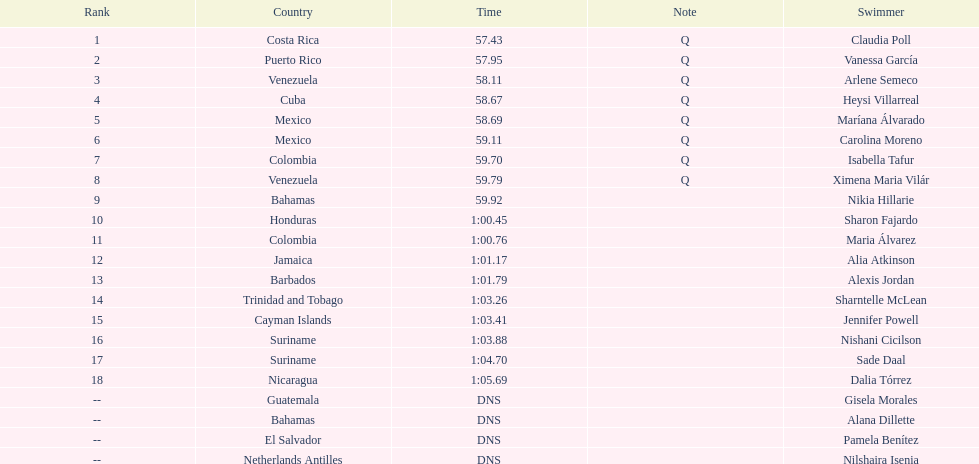How many swimmers had a time of at least 1:00 9. 